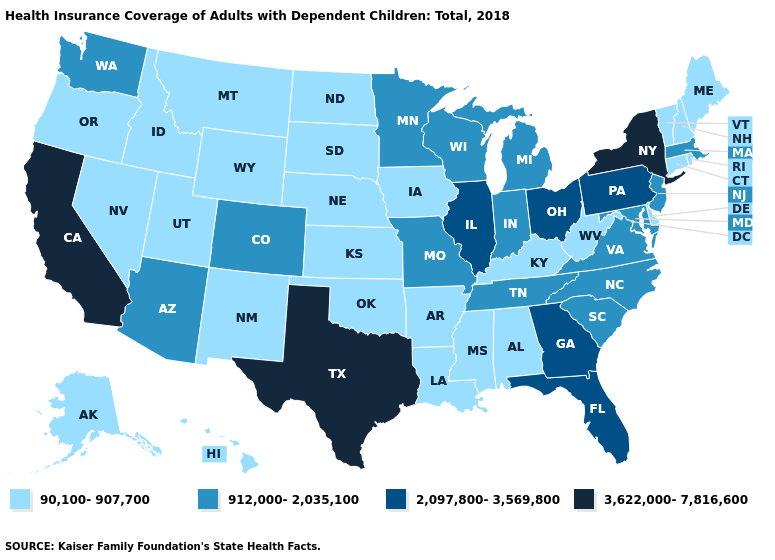Which states have the highest value in the USA?
Be succinct. California, New York, Texas. How many symbols are there in the legend?
Write a very short answer. 4. What is the lowest value in the USA?
Keep it brief. 90,100-907,700. Is the legend a continuous bar?
Give a very brief answer. No. What is the lowest value in the West?
Short answer required. 90,100-907,700. What is the value of Florida?
Keep it brief. 2,097,800-3,569,800. What is the lowest value in the USA?
Answer briefly. 90,100-907,700. Which states have the highest value in the USA?
Be succinct. California, New York, Texas. Name the states that have a value in the range 90,100-907,700?
Give a very brief answer. Alabama, Alaska, Arkansas, Connecticut, Delaware, Hawaii, Idaho, Iowa, Kansas, Kentucky, Louisiana, Maine, Mississippi, Montana, Nebraska, Nevada, New Hampshire, New Mexico, North Dakota, Oklahoma, Oregon, Rhode Island, South Dakota, Utah, Vermont, West Virginia, Wyoming. Is the legend a continuous bar?
Quick response, please. No. How many symbols are there in the legend?
Write a very short answer. 4. Does the map have missing data?
Write a very short answer. No. Which states have the highest value in the USA?
Short answer required. California, New York, Texas. Name the states that have a value in the range 2,097,800-3,569,800?
Keep it brief. Florida, Georgia, Illinois, Ohio, Pennsylvania. Among the states that border New Jersey , does Delaware have the lowest value?
Quick response, please. Yes. 